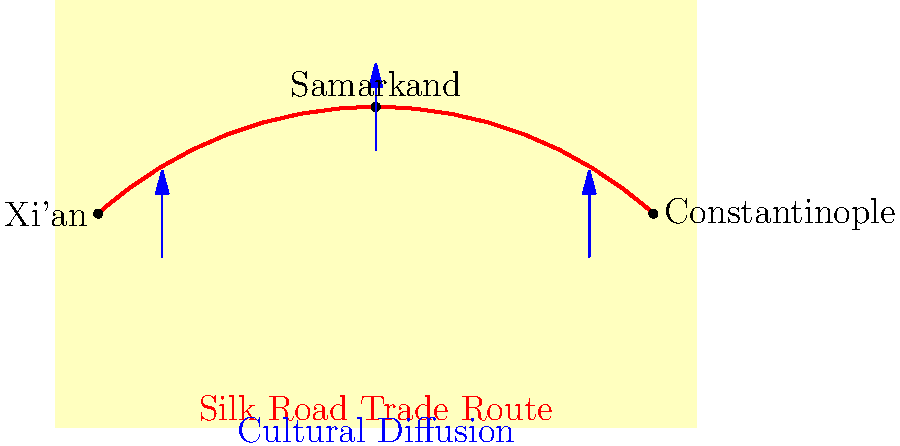Based on the map of the Silk Road trade route, which city served as a crucial midpoint for cultural exchange between the East and West, and why was its location significant for the diffusion of ideas and goods? To answer this question, let's analyze the map step-by-step:

1. The map shows three major cities along the Silk Road trade route:
   - Xi'an in the East
   - Samarkand in the center
   - Constantinople in the West

2. The red line represents the Silk Road trade route, connecting these cities.

3. Samarkand is positioned at the highest point on the trade route, suggesting its central location.

4. Blue arrows indicate cultural diffusion occurring at all three points, but Samarkand's arrow is the largest, implying more significant exchange.

5. Samarkand's central position makes it an ideal meeting point for traders and travelers from both East and West.

6. Its location allowed for:
   a) Accumulation of goods from both directions
   b) Exchange of ideas, technologies, and cultural practices
   c) Rest and resupply for long-distance travelers

7. Historically, Samarkand was known as a melting pot of cultures, languages, and religions due to its strategic position on the Silk Road.

Given these factors, Samarkand emerges as the crucial midpoint for cultural exchange between the East and West. Its central location made it a natural hub for the diffusion of ideas, goods, and cultural practices along the Silk Road.
Answer: Samarkand, due to its central location facilitating extensive cultural and economic exchange. 